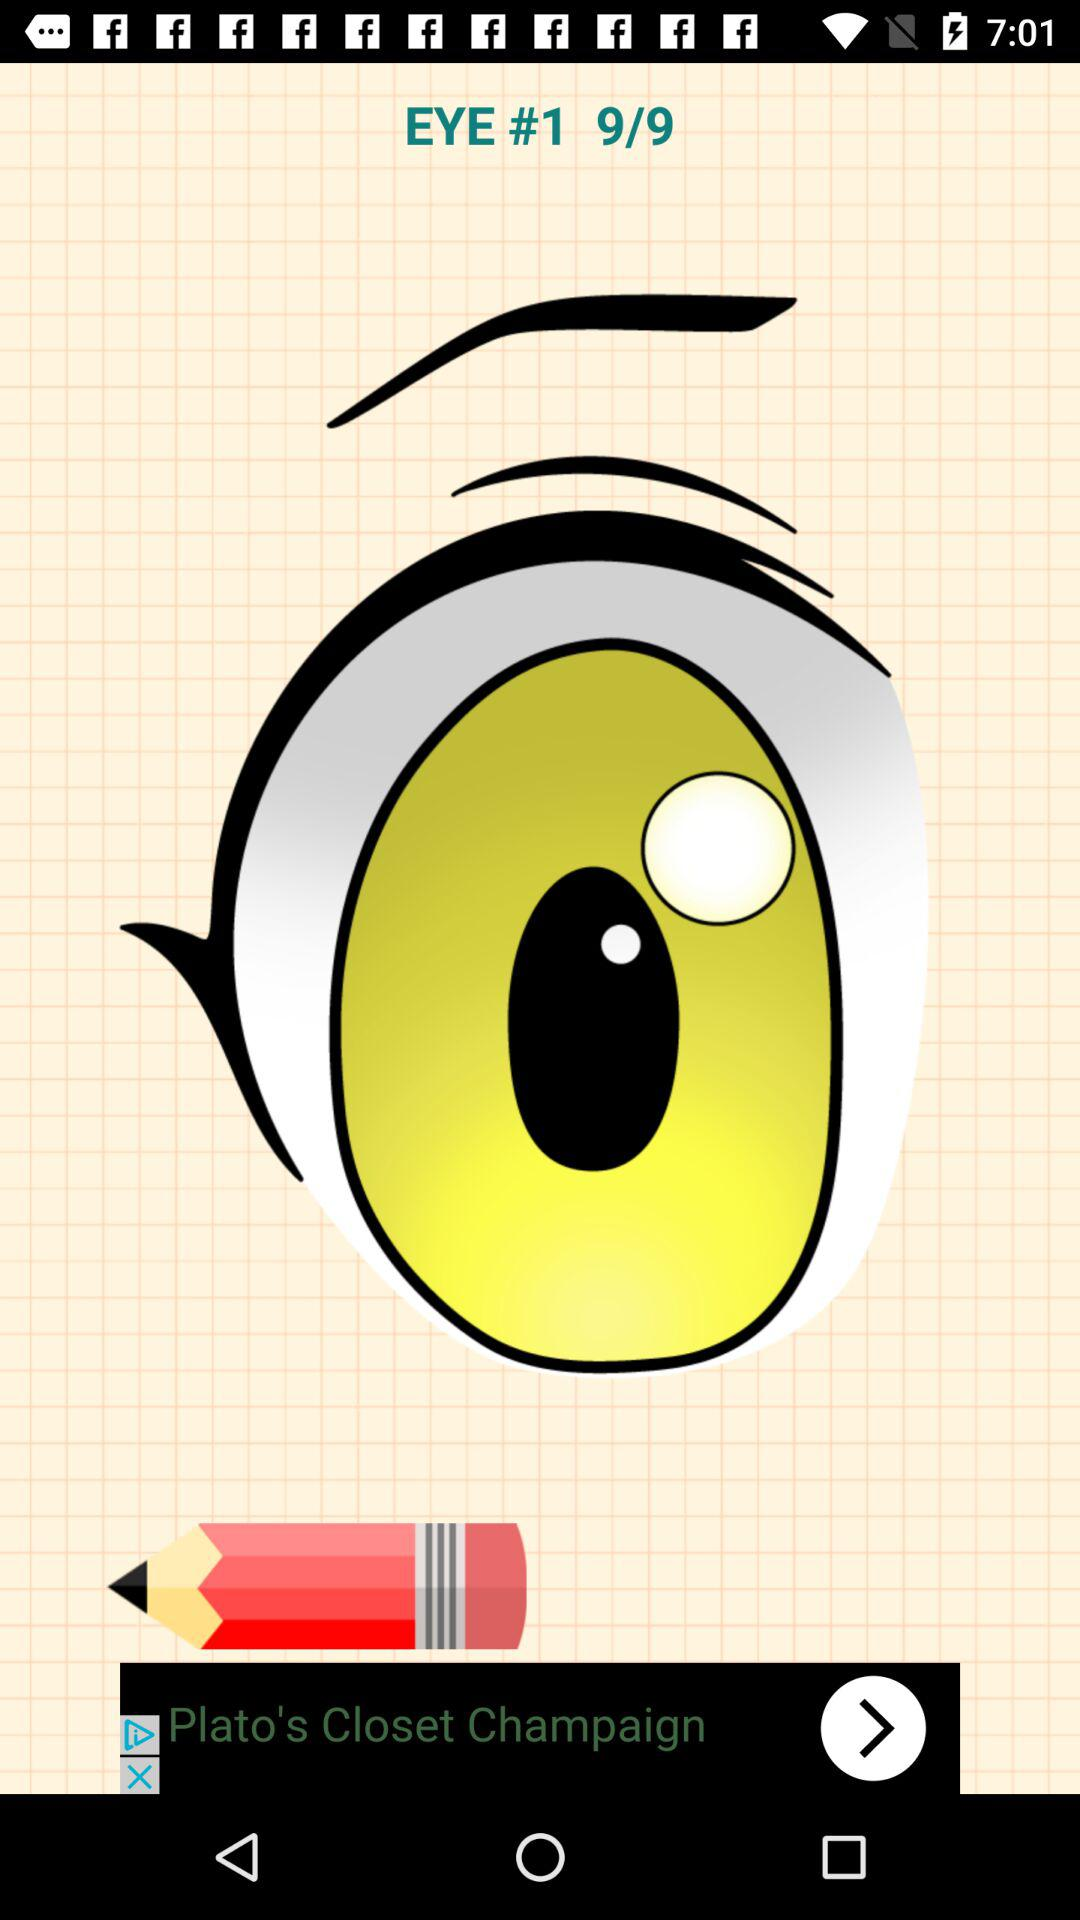Which page are we currently on? You are currently on the 9th page. 